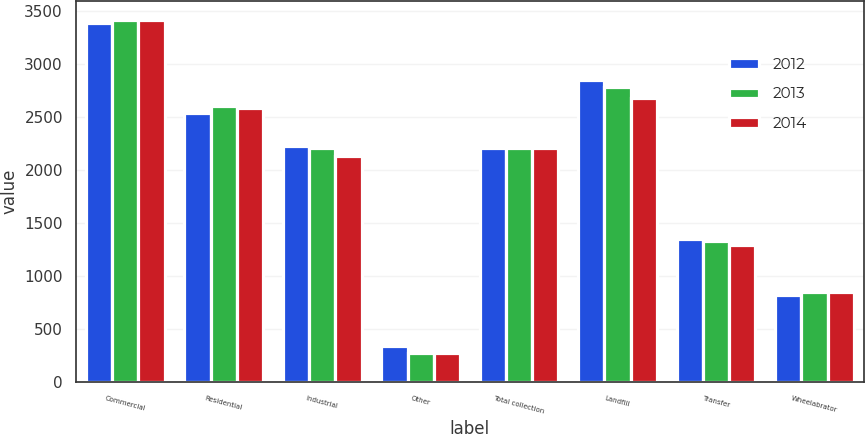<chart> <loc_0><loc_0><loc_500><loc_500><stacked_bar_chart><ecel><fcel>Commercial<fcel>Residential<fcel>Industrial<fcel>Other<fcel>Total collection<fcel>Landfill<fcel>Transfer<fcel>Wheelabrator<nl><fcel>2012<fcel>3393<fcel>2543<fcel>2231<fcel>340<fcel>2209<fcel>2849<fcel>1353<fcel>817<nl><fcel>2013<fcel>3423<fcel>2608<fcel>2209<fcel>273<fcel>2209<fcel>2790<fcel>1329<fcel>845<nl><fcel>2014<fcel>3417<fcel>2584<fcel>2129<fcel>275<fcel>2209<fcel>2685<fcel>1296<fcel>846<nl></chart> 